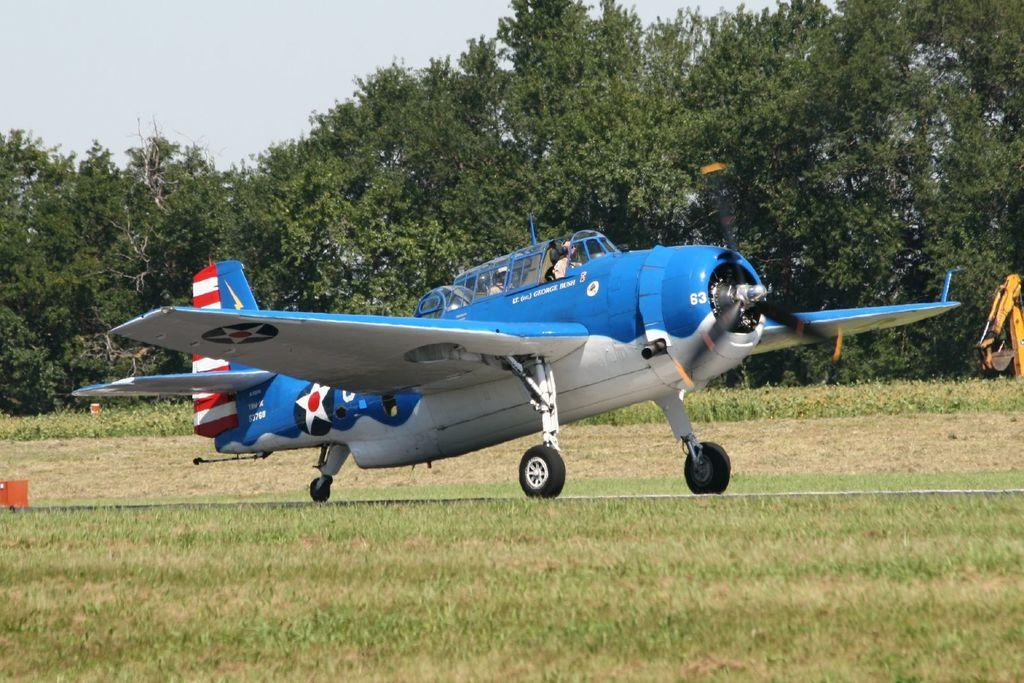What type of aircraft is in the picture? There is a utility aircraft in the picture. Where is the aircraft located? The aircraft is on the grass ground. What can be seen in the vicinity of the aircraft? Trees are present in the vicinity of the aircraft. What type of religion is practiced on the island in the image? There is no island present in the image, and therefore no religion can be associated with it. 